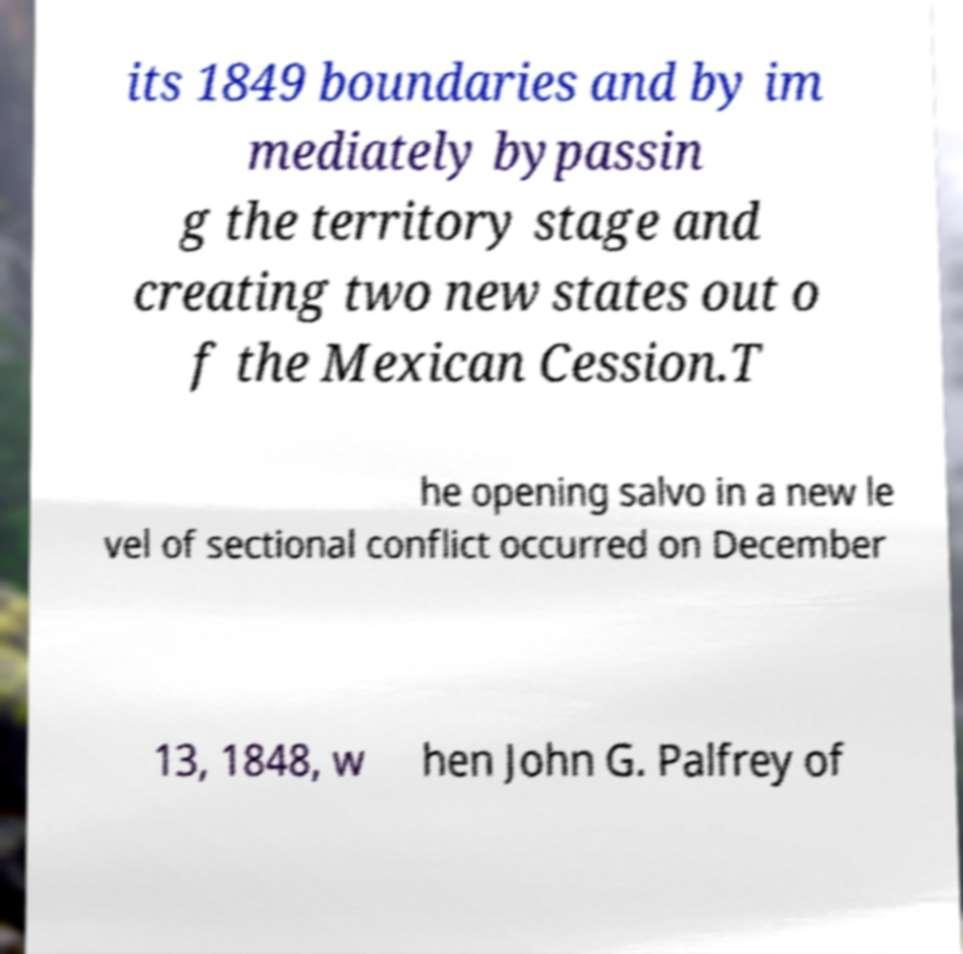I need the written content from this picture converted into text. Can you do that? its 1849 boundaries and by im mediately bypassin g the territory stage and creating two new states out o f the Mexican Cession.T he opening salvo in a new le vel of sectional conflict occurred on December 13, 1848, w hen John G. Palfrey of 